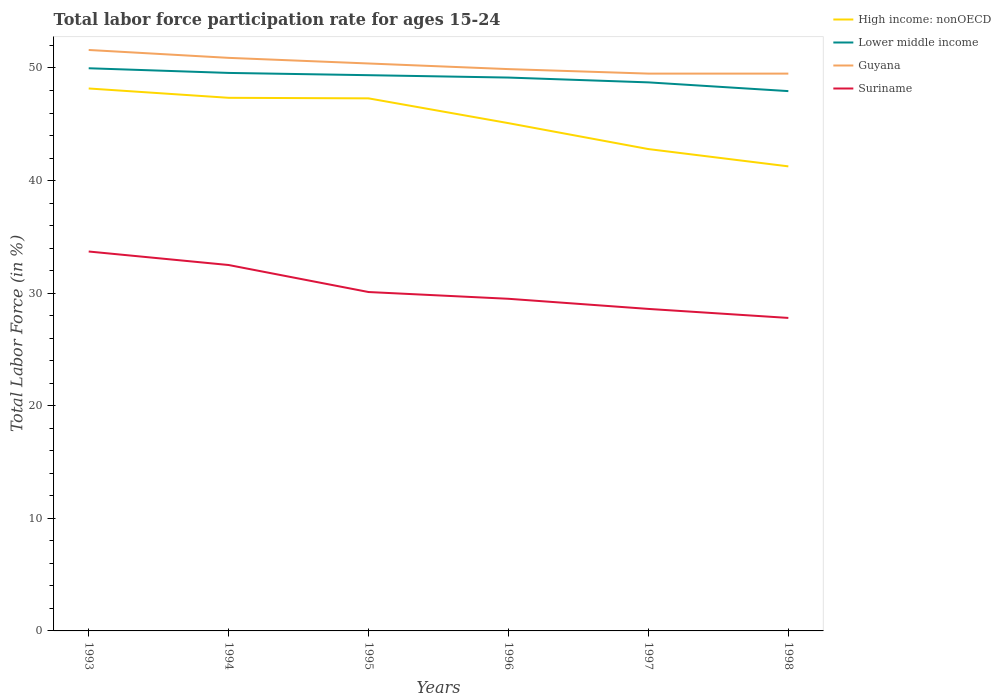Does the line corresponding to Guyana intersect with the line corresponding to Lower middle income?
Provide a succinct answer. No. Across all years, what is the maximum labor force participation rate in Lower middle income?
Ensure brevity in your answer.  47.95. In which year was the labor force participation rate in High income: nonOECD maximum?
Your response must be concise. 1998. What is the total labor force participation rate in High income: nonOECD in the graph?
Provide a succinct answer. 4.55. What is the difference between the highest and the second highest labor force participation rate in Guyana?
Provide a short and direct response. 2.1. Is the labor force participation rate in Lower middle income strictly greater than the labor force participation rate in Suriname over the years?
Give a very brief answer. No. How many lines are there?
Provide a short and direct response. 4. How many years are there in the graph?
Your response must be concise. 6. What is the difference between two consecutive major ticks on the Y-axis?
Provide a succinct answer. 10. Are the values on the major ticks of Y-axis written in scientific E-notation?
Provide a succinct answer. No. Does the graph contain any zero values?
Offer a terse response. No. Does the graph contain grids?
Provide a succinct answer. No. How are the legend labels stacked?
Ensure brevity in your answer.  Vertical. What is the title of the graph?
Ensure brevity in your answer.  Total labor force participation rate for ages 15-24. What is the Total Labor Force (in %) in High income: nonOECD in 1993?
Your answer should be very brief. 48.18. What is the Total Labor Force (in %) in Lower middle income in 1993?
Your response must be concise. 49.98. What is the Total Labor Force (in %) in Guyana in 1993?
Give a very brief answer. 51.6. What is the Total Labor Force (in %) of Suriname in 1993?
Give a very brief answer. 33.7. What is the Total Labor Force (in %) of High income: nonOECD in 1994?
Your answer should be very brief. 47.35. What is the Total Labor Force (in %) in Lower middle income in 1994?
Ensure brevity in your answer.  49.56. What is the Total Labor Force (in %) of Guyana in 1994?
Provide a succinct answer. 50.9. What is the Total Labor Force (in %) of Suriname in 1994?
Give a very brief answer. 32.5. What is the Total Labor Force (in %) of High income: nonOECD in 1995?
Provide a short and direct response. 47.3. What is the Total Labor Force (in %) of Lower middle income in 1995?
Provide a succinct answer. 49.36. What is the Total Labor Force (in %) in Guyana in 1995?
Offer a terse response. 50.4. What is the Total Labor Force (in %) in Suriname in 1995?
Offer a terse response. 30.1. What is the Total Labor Force (in %) of High income: nonOECD in 1996?
Offer a very short reply. 45.1. What is the Total Labor Force (in %) in Lower middle income in 1996?
Ensure brevity in your answer.  49.15. What is the Total Labor Force (in %) of Guyana in 1996?
Your response must be concise. 49.9. What is the Total Labor Force (in %) of Suriname in 1996?
Give a very brief answer. 29.5. What is the Total Labor Force (in %) of High income: nonOECD in 1997?
Give a very brief answer. 42.8. What is the Total Labor Force (in %) of Lower middle income in 1997?
Offer a very short reply. 48.72. What is the Total Labor Force (in %) in Guyana in 1997?
Ensure brevity in your answer.  49.5. What is the Total Labor Force (in %) of Suriname in 1997?
Make the answer very short. 28.6. What is the Total Labor Force (in %) of High income: nonOECD in 1998?
Your answer should be compact. 41.26. What is the Total Labor Force (in %) in Lower middle income in 1998?
Give a very brief answer. 47.95. What is the Total Labor Force (in %) in Guyana in 1998?
Your answer should be compact. 49.5. What is the Total Labor Force (in %) in Suriname in 1998?
Provide a short and direct response. 27.8. Across all years, what is the maximum Total Labor Force (in %) in High income: nonOECD?
Provide a succinct answer. 48.18. Across all years, what is the maximum Total Labor Force (in %) of Lower middle income?
Your answer should be compact. 49.98. Across all years, what is the maximum Total Labor Force (in %) of Guyana?
Offer a very short reply. 51.6. Across all years, what is the maximum Total Labor Force (in %) of Suriname?
Provide a short and direct response. 33.7. Across all years, what is the minimum Total Labor Force (in %) in High income: nonOECD?
Offer a very short reply. 41.26. Across all years, what is the minimum Total Labor Force (in %) of Lower middle income?
Your answer should be compact. 47.95. Across all years, what is the minimum Total Labor Force (in %) in Guyana?
Offer a terse response. 49.5. Across all years, what is the minimum Total Labor Force (in %) in Suriname?
Keep it short and to the point. 27.8. What is the total Total Labor Force (in %) of High income: nonOECD in the graph?
Keep it short and to the point. 271.99. What is the total Total Labor Force (in %) in Lower middle income in the graph?
Your response must be concise. 294.72. What is the total Total Labor Force (in %) of Guyana in the graph?
Provide a short and direct response. 301.8. What is the total Total Labor Force (in %) of Suriname in the graph?
Offer a terse response. 182.2. What is the difference between the Total Labor Force (in %) in High income: nonOECD in 1993 and that in 1994?
Ensure brevity in your answer.  0.83. What is the difference between the Total Labor Force (in %) of Lower middle income in 1993 and that in 1994?
Offer a very short reply. 0.41. What is the difference between the Total Labor Force (in %) in Guyana in 1993 and that in 1994?
Provide a succinct answer. 0.7. What is the difference between the Total Labor Force (in %) in Suriname in 1993 and that in 1994?
Provide a short and direct response. 1.2. What is the difference between the Total Labor Force (in %) of High income: nonOECD in 1993 and that in 1995?
Your answer should be very brief. 0.88. What is the difference between the Total Labor Force (in %) in Lower middle income in 1993 and that in 1995?
Keep it short and to the point. 0.62. What is the difference between the Total Labor Force (in %) of Guyana in 1993 and that in 1995?
Make the answer very short. 1.2. What is the difference between the Total Labor Force (in %) in High income: nonOECD in 1993 and that in 1996?
Make the answer very short. 3.08. What is the difference between the Total Labor Force (in %) in Lower middle income in 1993 and that in 1996?
Your response must be concise. 0.83. What is the difference between the Total Labor Force (in %) in High income: nonOECD in 1993 and that in 1997?
Your response must be concise. 5.38. What is the difference between the Total Labor Force (in %) of Lower middle income in 1993 and that in 1997?
Provide a short and direct response. 1.25. What is the difference between the Total Labor Force (in %) in High income: nonOECD in 1993 and that in 1998?
Your response must be concise. 6.92. What is the difference between the Total Labor Force (in %) in Lower middle income in 1993 and that in 1998?
Your response must be concise. 2.03. What is the difference between the Total Labor Force (in %) in Suriname in 1993 and that in 1998?
Your response must be concise. 5.9. What is the difference between the Total Labor Force (in %) of High income: nonOECD in 1994 and that in 1995?
Offer a terse response. 0.05. What is the difference between the Total Labor Force (in %) of Lower middle income in 1994 and that in 1995?
Keep it short and to the point. 0.2. What is the difference between the Total Labor Force (in %) in Suriname in 1994 and that in 1995?
Your answer should be very brief. 2.4. What is the difference between the Total Labor Force (in %) in High income: nonOECD in 1994 and that in 1996?
Give a very brief answer. 2.25. What is the difference between the Total Labor Force (in %) in Lower middle income in 1994 and that in 1996?
Your answer should be very brief. 0.41. What is the difference between the Total Labor Force (in %) of High income: nonOECD in 1994 and that in 1997?
Provide a short and direct response. 4.55. What is the difference between the Total Labor Force (in %) in Lower middle income in 1994 and that in 1997?
Provide a succinct answer. 0.84. What is the difference between the Total Labor Force (in %) of Guyana in 1994 and that in 1997?
Your answer should be very brief. 1.4. What is the difference between the Total Labor Force (in %) in Suriname in 1994 and that in 1997?
Ensure brevity in your answer.  3.9. What is the difference between the Total Labor Force (in %) in High income: nonOECD in 1994 and that in 1998?
Offer a terse response. 6.09. What is the difference between the Total Labor Force (in %) in Lower middle income in 1994 and that in 1998?
Offer a very short reply. 1.62. What is the difference between the Total Labor Force (in %) of High income: nonOECD in 1995 and that in 1996?
Your response must be concise. 2.2. What is the difference between the Total Labor Force (in %) in Lower middle income in 1995 and that in 1996?
Offer a very short reply. 0.21. What is the difference between the Total Labor Force (in %) of Guyana in 1995 and that in 1996?
Your answer should be very brief. 0.5. What is the difference between the Total Labor Force (in %) in High income: nonOECD in 1995 and that in 1997?
Provide a succinct answer. 4.5. What is the difference between the Total Labor Force (in %) in Lower middle income in 1995 and that in 1997?
Offer a terse response. 0.64. What is the difference between the Total Labor Force (in %) in Guyana in 1995 and that in 1997?
Your answer should be very brief. 0.9. What is the difference between the Total Labor Force (in %) of High income: nonOECD in 1995 and that in 1998?
Provide a short and direct response. 6.04. What is the difference between the Total Labor Force (in %) in Lower middle income in 1995 and that in 1998?
Provide a succinct answer. 1.41. What is the difference between the Total Labor Force (in %) of Suriname in 1995 and that in 1998?
Offer a terse response. 2.3. What is the difference between the Total Labor Force (in %) in High income: nonOECD in 1996 and that in 1997?
Offer a very short reply. 2.3. What is the difference between the Total Labor Force (in %) of Lower middle income in 1996 and that in 1997?
Offer a very short reply. 0.43. What is the difference between the Total Labor Force (in %) in Guyana in 1996 and that in 1997?
Provide a short and direct response. 0.4. What is the difference between the Total Labor Force (in %) in Suriname in 1996 and that in 1997?
Offer a very short reply. 0.9. What is the difference between the Total Labor Force (in %) of High income: nonOECD in 1996 and that in 1998?
Offer a terse response. 3.84. What is the difference between the Total Labor Force (in %) of Lower middle income in 1996 and that in 1998?
Provide a succinct answer. 1.2. What is the difference between the Total Labor Force (in %) in High income: nonOECD in 1997 and that in 1998?
Make the answer very short. 1.54. What is the difference between the Total Labor Force (in %) in Lower middle income in 1997 and that in 1998?
Ensure brevity in your answer.  0.78. What is the difference between the Total Labor Force (in %) of High income: nonOECD in 1993 and the Total Labor Force (in %) of Lower middle income in 1994?
Your answer should be very brief. -1.38. What is the difference between the Total Labor Force (in %) of High income: nonOECD in 1993 and the Total Labor Force (in %) of Guyana in 1994?
Offer a terse response. -2.72. What is the difference between the Total Labor Force (in %) of High income: nonOECD in 1993 and the Total Labor Force (in %) of Suriname in 1994?
Ensure brevity in your answer.  15.68. What is the difference between the Total Labor Force (in %) in Lower middle income in 1993 and the Total Labor Force (in %) in Guyana in 1994?
Make the answer very short. -0.92. What is the difference between the Total Labor Force (in %) of Lower middle income in 1993 and the Total Labor Force (in %) of Suriname in 1994?
Provide a short and direct response. 17.48. What is the difference between the Total Labor Force (in %) of Guyana in 1993 and the Total Labor Force (in %) of Suriname in 1994?
Your response must be concise. 19.1. What is the difference between the Total Labor Force (in %) in High income: nonOECD in 1993 and the Total Labor Force (in %) in Lower middle income in 1995?
Offer a terse response. -1.18. What is the difference between the Total Labor Force (in %) of High income: nonOECD in 1993 and the Total Labor Force (in %) of Guyana in 1995?
Provide a succinct answer. -2.22. What is the difference between the Total Labor Force (in %) in High income: nonOECD in 1993 and the Total Labor Force (in %) in Suriname in 1995?
Offer a very short reply. 18.08. What is the difference between the Total Labor Force (in %) of Lower middle income in 1993 and the Total Labor Force (in %) of Guyana in 1995?
Give a very brief answer. -0.42. What is the difference between the Total Labor Force (in %) in Lower middle income in 1993 and the Total Labor Force (in %) in Suriname in 1995?
Provide a succinct answer. 19.88. What is the difference between the Total Labor Force (in %) in Guyana in 1993 and the Total Labor Force (in %) in Suriname in 1995?
Give a very brief answer. 21.5. What is the difference between the Total Labor Force (in %) in High income: nonOECD in 1993 and the Total Labor Force (in %) in Lower middle income in 1996?
Give a very brief answer. -0.97. What is the difference between the Total Labor Force (in %) in High income: nonOECD in 1993 and the Total Labor Force (in %) in Guyana in 1996?
Provide a short and direct response. -1.72. What is the difference between the Total Labor Force (in %) of High income: nonOECD in 1993 and the Total Labor Force (in %) of Suriname in 1996?
Make the answer very short. 18.68. What is the difference between the Total Labor Force (in %) in Lower middle income in 1993 and the Total Labor Force (in %) in Guyana in 1996?
Your answer should be very brief. 0.08. What is the difference between the Total Labor Force (in %) in Lower middle income in 1993 and the Total Labor Force (in %) in Suriname in 1996?
Your answer should be compact. 20.48. What is the difference between the Total Labor Force (in %) in Guyana in 1993 and the Total Labor Force (in %) in Suriname in 1996?
Give a very brief answer. 22.1. What is the difference between the Total Labor Force (in %) in High income: nonOECD in 1993 and the Total Labor Force (in %) in Lower middle income in 1997?
Make the answer very short. -0.54. What is the difference between the Total Labor Force (in %) of High income: nonOECD in 1993 and the Total Labor Force (in %) of Guyana in 1997?
Your answer should be very brief. -1.32. What is the difference between the Total Labor Force (in %) in High income: nonOECD in 1993 and the Total Labor Force (in %) in Suriname in 1997?
Make the answer very short. 19.58. What is the difference between the Total Labor Force (in %) of Lower middle income in 1993 and the Total Labor Force (in %) of Guyana in 1997?
Your answer should be very brief. 0.48. What is the difference between the Total Labor Force (in %) of Lower middle income in 1993 and the Total Labor Force (in %) of Suriname in 1997?
Ensure brevity in your answer.  21.38. What is the difference between the Total Labor Force (in %) in High income: nonOECD in 1993 and the Total Labor Force (in %) in Lower middle income in 1998?
Give a very brief answer. 0.23. What is the difference between the Total Labor Force (in %) in High income: nonOECD in 1993 and the Total Labor Force (in %) in Guyana in 1998?
Provide a short and direct response. -1.32. What is the difference between the Total Labor Force (in %) in High income: nonOECD in 1993 and the Total Labor Force (in %) in Suriname in 1998?
Your answer should be very brief. 20.38. What is the difference between the Total Labor Force (in %) in Lower middle income in 1993 and the Total Labor Force (in %) in Guyana in 1998?
Keep it short and to the point. 0.48. What is the difference between the Total Labor Force (in %) in Lower middle income in 1993 and the Total Labor Force (in %) in Suriname in 1998?
Provide a succinct answer. 22.18. What is the difference between the Total Labor Force (in %) of Guyana in 1993 and the Total Labor Force (in %) of Suriname in 1998?
Your answer should be compact. 23.8. What is the difference between the Total Labor Force (in %) in High income: nonOECD in 1994 and the Total Labor Force (in %) in Lower middle income in 1995?
Make the answer very short. -2.01. What is the difference between the Total Labor Force (in %) in High income: nonOECD in 1994 and the Total Labor Force (in %) in Guyana in 1995?
Your answer should be compact. -3.05. What is the difference between the Total Labor Force (in %) in High income: nonOECD in 1994 and the Total Labor Force (in %) in Suriname in 1995?
Give a very brief answer. 17.25. What is the difference between the Total Labor Force (in %) of Lower middle income in 1994 and the Total Labor Force (in %) of Guyana in 1995?
Your response must be concise. -0.84. What is the difference between the Total Labor Force (in %) in Lower middle income in 1994 and the Total Labor Force (in %) in Suriname in 1995?
Give a very brief answer. 19.46. What is the difference between the Total Labor Force (in %) of Guyana in 1994 and the Total Labor Force (in %) of Suriname in 1995?
Ensure brevity in your answer.  20.8. What is the difference between the Total Labor Force (in %) of High income: nonOECD in 1994 and the Total Labor Force (in %) of Lower middle income in 1996?
Provide a short and direct response. -1.8. What is the difference between the Total Labor Force (in %) of High income: nonOECD in 1994 and the Total Labor Force (in %) of Guyana in 1996?
Provide a succinct answer. -2.55. What is the difference between the Total Labor Force (in %) of High income: nonOECD in 1994 and the Total Labor Force (in %) of Suriname in 1996?
Provide a succinct answer. 17.85. What is the difference between the Total Labor Force (in %) of Lower middle income in 1994 and the Total Labor Force (in %) of Guyana in 1996?
Ensure brevity in your answer.  -0.34. What is the difference between the Total Labor Force (in %) of Lower middle income in 1994 and the Total Labor Force (in %) of Suriname in 1996?
Provide a short and direct response. 20.06. What is the difference between the Total Labor Force (in %) in Guyana in 1994 and the Total Labor Force (in %) in Suriname in 1996?
Provide a succinct answer. 21.4. What is the difference between the Total Labor Force (in %) of High income: nonOECD in 1994 and the Total Labor Force (in %) of Lower middle income in 1997?
Make the answer very short. -1.37. What is the difference between the Total Labor Force (in %) in High income: nonOECD in 1994 and the Total Labor Force (in %) in Guyana in 1997?
Your response must be concise. -2.15. What is the difference between the Total Labor Force (in %) of High income: nonOECD in 1994 and the Total Labor Force (in %) of Suriname in 1997?
Provide a succinct answer. 18.75. What is the difference between the Total Labor Force (in %) in Lower middle income in 1994 and the Total Labor Force (in %) in Guyana in 1997?
Your answer should be compact. 0.06. What is the difference between the Total Labor Force (in %) in Lower middle income in 1994 and the Total Labor Force (in %) in Suriname in 1997?
Your answer should be very brief. 20.96. What is the difference between the Total Labor Force (in %) in Guyana in 1994 and the Total Labor Force (in %) in Suriname in 1997?
Your answer should be very brief. 22.3. What is the difference between the Total Labor Force (in %) of High income: nonOECD in 1994 and the Total Labor Force (in %) of Lower middle income in 1998?
Give a very brief answer. -0.59. What is the difference between the Total Labor Force (in %) of High income: nonOECD in 1994 and the Total Labor Force (in %) of Guyana in 1998?
Your answer should be compact. -2.15. What is the difference between the Total Labor Force (in %) of High income: nonOECD in 1994 and the Total Labor Force (in %) of Suriname in 1998?
Your response must be concise. 19.55. What is the difference between the Total Labor Force (in %) in Lower middle income in 1994 and the Total Labor Force (in %) in Guyana in 1998?
Keep it short and to the point. 0.06. What is the difference between the Total Labor Force (in %) in Lower middle income in 1994 and the Total Labor Force (in %) in Suriname in 1998?
Make the answer very short. 21.76. What is the difference between the Total Labor Force (in %) in Guyana in 1994 and the Total Labor Force (in %) in Suriname in 1998?
Your answer should be very brief. 23.1. What is the difference between the Total Labor Force (in %) in High income: nonOECD in 1995 and the Total Labor Force (in %) in Lower middle income in 1996?
Ensure brevity in your answer.  -1.85. What is the difference between the Total Labor Force (in %) in High income: nonOECD in 1995 and the Total Labor Force (in %) in Guyana in 1996?
Provide a short and direct response. -2.6. What is the difference between the Total Labor Force (in %) of High income: nonOECD in 1995 and the Total Labor Force (in %) of Suriname in 1996?
Give a very brief answer. 17.8. What is the difference between the Total Labor Force (in %) in Lower middle income in 1995 and the Total Labor Force (in %) in Guyana in 1996?
Provide a succinct answer. -0.54. What is the difference between the Total Labor Force (in %) of Lower middle income in 1995 and the Total Labor Force (in %) of Suriname in 1996?
Offer a terse response. 19.86. What is the difference between the Total Labor Force (in %) in Guyana in 1995 and the Total Labor Force (in %) in Suriname in 1996?
Ensure brevity in your answer.  20.9. What is the difference between the Total Labor Force (in %) of High income: nonOECD in 1995 and the Total Labor Force (in %) of Lower middle income in 1997?
Give a very brief answer. -1.42. What is the difference between the Total Labor Force (in %) in High income: nonOECD in 1995 and the Total Labor Force (in %) in Guyana in 1997?
Ensure brevity in your answer.  -2.2. What is the difference between the Total Labor Force (in %) of High income: nonOECD in 1995 and the Total Labor Force (in %) of Suriname in 1997?
Provide a succinct answer. 18.7. What is the difference between the Total Labor Force (in %) of Lower middle income in 1995 and the Total Labor Force (in %) of Guyana in 1997?
Provide a succinct answer. -0.14. What is the difference between the Total Labor Force (in %) in Lower middle income in 1995 and the Total Labor Force (in %) in Suriname in 1997?
Make the answer very short. 20.76. What is the difference between the Total Labor Force (in %) of Guyana in 1995 and the Total Labor Force (in %) of Suriname in 1997?
Your answer should be very brief. 21.8. What is the difference between the Total Labor Force (in %) of High income: nonOECD in 1995 and the Total Labor Force (in %) of Lower middle income in 1998?
Offer a very short reply. -0.64. What is the difference between the Total Labor Force (in %) of High income: nonOECD in 1995 and the Total Labor Force (in %) of Guyana in 1998?
Your response must be concise. -2.2. What is the difference between the Total Labor Force (in %) of High income: nonOECD in 1995 and the Total Labor Force (in %) of Suriname in 1998?
Offer a terse response. 19.5. What is the difference between the Total Labor Force (in %) in Lower middle income in 1995 and the Total Labor Force (in %) in Guyana in 1998?
Provide a succinct answer. -0.14. What is the difference between the Total Labor Force (in %) in Lower middle income in 1995 and the Total Labor Force (in %) in Suriname in 1998?
Provide a succinct answer. 21.56. What is the difference between the Total Labor Force (in %) in Guyana in 1995 and the Total Labor Force (in %) in Suriname in 1998?
Offer a very short reply. 22.6. What is the difference between the Total Labor Force (in %) in High income: nonOECD in 1996 and the Total Labor Force (in %) in Lower middle income in 1997?
Provide a short and direct response. -3.62. What is the difference between the Total Labor Force (in %) of High income: nonOECD in 1996 and the Total Labor Force (in %) of Guyana in 1997?
Offer a very short reply. -4.4. What is the difference between the Total Labor Force (in %) of High income: nonOECD in 1996 and the Total Labor Force (in %) of Suriname in 1997?
Provide a succinct answer. 16.5. What is the difference between the Total Labor Force (in %) of Lower middle income in 1996 and the Total Labor Force (in %) of Guyana in 1997?
Give a very brief answer. -0.35. What is the difference between the Total Labor Force (in %) of Lower middle income in 1996 and the Total Labor Force (in %) of Suriname in 1997?
Your response must be concise. 20.55. What is the difference between the Total Labor Force (in %) of Guyana in 1996 and the Total Labor Force (in %) of Suriname in 1997?
Keep it short and to the point. 21.3. What is the difference between the Total Labor Force (in %) in High income: nonOECD in 1996 and the Total Labor Force (in %) in Lower middle income in 1998?
Give a very brief answer. -2.85. What is the difference between the Total Labor Force (in %) in High income: nonOECD in 1996 and the Total Labor Force (in %) in Guyana in 1998?
Make the answer very short. -4.4. What is the difference between the Total Labor Force (in %) in High income: nonOECD in 1996 and the Total Labor Force (in %) in Suriname in 1998?
Your response must be concise. 17.3. What is the difference between the Total Labor Force (in %) of Lower middle income in 1996 and the Total Labor Force (in %) of Guyana in 1998?
Make the answer very short. -0.35. What is the difference between the Total Labor Force (in %) of Lower middle income in 1996 and the Total Labor Force (in %) of Suriname in 1998?
Give a very brief answer. 21.35. What is the difference between the Total Labor Force (in %) in Guyana in 1996 and the Total Labor Force (in %) in Suriname in 1998?
Provide a short and direct response. 22.1. What is the difference between the Total Labor Force (in %) in High income: nonOECD in 1997 and the Total Labor Force (in %) in Lower middle income in 1998?
Provide a short and direct response. -5.15. What is the difference between the Total Labor Force (in %) in High income: nonOECD in 1997 and the Total Labor Force (in %) in Guyana in 1998?
Offer a terse response. -6.7. What is the difference between the Total Labor Force (in %) of High income: nonOECD in 1997 and the Total Labor Force (in %) of Suriname in 1998?
Give a very brief answer. 15. What is the difference between the Total Labor Force (in %) in Lower middle income in 1997 and the Total Labor Force (in %) in Guyana in 1998?
Give a very brief answer. -0.78. What is the difference between the Total Labor Force (in %) of Lower middle income in 1997 and the Total Labor Force (in %) of Suriname in 1998?
Your answer should be very brief. 20.92. What is the difference between the Total Labor Force (in %) in Guyana in 1997 and the Total Labor Force (in %) in Suriname in 1998?
Give a very brief answer. 21.7. What is the average Total Labor Force (in %) in High income: nonOECD per year?
Provide a succinct answer. 45.33. What is the average Total Labor Force (in %) of Lower middle income per year?
Offer a terse response. 49.12. What is the average Total Labor Force (in %) in Guyana per year?
Your response must be concise. 50.3. What is the average Total Labor Force (in %) in Suriname per year?
Your answer should be very brief. 30.37. In the year 1993, what is the difference between the Total Labor Force (in %) in High income: nonOECD and Total Labor Force (in %) in Lower middle income?
Offer a very short reply. -1.8. In the year 1993, what is the difference between the Total Labor Force (in %) in High income: nonOECD and Total Labor Force (in %) in Guyana?
Make the answer very short. -3.42. In the year 1993, what is the difference between the Total Labor Force (in %) of High income: nonOECD and Total Labor Force (in %) of Suriname?
Offer a terse response. 14.48. In the year 1993, what is the difference between the Total Labor Force (in %) in Lower middle income and Total Labor Force (in %) in Guyana?
Give a very brief answer. -1.62. In the year 1993, what is the difference between the Total Labor Force (in %) of Lower middle income and Total Labor Force (in %) of Suriname?
Your response must be concise. 16.28. In the year 1993, what is the difference between the Total Labor Force (in %) of Guyana and Total Labor Force (in %) of Suriname?
Make the answer very short. 17.9. In the year 1994, what is the difference between the Total Labor Force (in %) of High income: nonOECD and Total Labor Force (in %) of Lower middle income?
Your response must be concise. -2.21. In the year 1994, what is the difference between the Total Labor Force (in %) of High income: nonOECD and Total Labor Force (in %) of Guyana?
Offer a terse response. -3.55. In the year 1994, what is the difference between the Total Labor Force (in %) of High income: nonOECD and Total Labor Force (in %) of Suriname?
Your response must be concise. 14.85. In the year 1994, what is the difference between the Total Labor Force (in %) of Lower middle income and Total Labor Force (in %) of Guyana?
Offer a very short reply. -1.34. In the year 1994, what is the difference between the Total Labor Force (in %) in Lower middle income and Total Labor Force (in %) in Suriname?
Your response must be concise. 17.06. In the year 1994, what is the difference between the Total Labor Force (in %) in Guyana and Total Labor Force (in %) in Suriname?
Your answer should be compact. 18.4. In the year 1995, what is the difference between the Total Labor Force (in %) of High income: nonOECD and Total Labor Force (in %) of Lower middle income?
Make the answer very short. -2.06. In the year 1995, what is the difference between the Total Labor Force (in %) of High income: nonOECD and Total Labor Force (in %) of Guyana?
Provide a succinct answer. -3.1. In the year 1995, what is the difference between the Total Labor Force (in %) in High income: nonOECD and Total Labor Force (in %) in Suriname?
Offer a terse response. 17.2. In the year 1995, what is the difference between the Total Labor Force (in %) of Lower middle income and Total Labor Force (in %) of Guyana?
Your answer should be very brief. -1.04. In the year 1995, what is the difference between the Total Labor Force (in %) of Lower middle income and Total Labor Force (in %) of Suriname?
Offer a terse response. 19.26. In the year 1995, what is the difference between the Total Labor Force (in %) in Guyana and Total Labor Force (in %) in Suriname?
Provide a short and direct response. 20.3. In the year 1996, what is the difference between the Total Labor Force (in %) of High income: nonOECD and Total Labor Force (in %) of Lower middle income?
Ensure brevity in your answer.  -4.05. In the year 1996, what is the difference between the Total Labor Force (in %) of High income: nonOECD and Total Labor Force (in %) of Guyana?
Ensure brevity in your answer.  -4.8. In the year 1996, what is the difference between the Total Labor Force (in %) in High income: nonOECD and Total Labor Force (in %) in Suriname?
Give a very brief answer. 15.6. In the year 1996, what is the difference between the Total Labor Force (in %) of Lower middle income and Total Labor Force (in %) of Guyana?
Provide a short and direct response. -0.75. In the year 1996, what is the difference between the Total Labor Force (in %) in Lower middle income and Total Labor Force (in %) in Suriname?
Your answer should be very brief. 19.65. In the year 1996, what is the difference between the Total Labor Force (in %) of Guyana and Total Labor Force (in %) of Suriname?
Offer a terse response. 20.4. In the year 1997, what is the difference between the Total Labor Force (in %) of High income: nonOECD and Total Labor Force (in %) of Lower middle income?
Keep it short and to the point. -5.92. In the year 1997, what is the difference between the Total Labor Force (in %) of High income: nonOECD and Total Labor Force (in %) of Guyana?
Make the answer very short. -6.7. In the year 1997, what is the difference between the Total Labor Force (in %) in High income: nonOECD and Total Labor Force (in %) in Suriname?
Provide a succinct answer. 14.2. In the year 1997, what is the difference between the Total Labor Force (in %) in Lower middle income and Total Labor Force (in %) in Guyana?
Ensure brevity in your answer.  -0.78. In the year 1997, what is the difference between the Total Labor Force (in %) in Lower middle income and Total Labor Force (in %) in Suriname?
Offer a very short reply. 20.12. In the year 1997, what is the difference between the Total Labor Force (in %) in Guyana and Total Labor Force (in %) in Suriname?
Provide a succinct answer. 20.9. In the year 1998, what is the difference between the Total Labor Force (in %) in High income: nonOECD and Total Labor Force (in %) in Lower middle income?
Your response must be concise. -6.68. In the year 1998, what is the difference between the Total Labor Force (in %) in High income: nonOECD and Total Labor Force (in %) in Guyana?
Offer a terse response. -8.24. In the year 1998, what is the difference between the Total Labor Force (in %) in High income: nonOECD and Total Labor Force (in %) in Suriname?
Your answer should be compact. 13.46. In the year 1998, what is the difference between the Total Labor Force (in %) in Lower middle income and Total Labor Force (in %) in Guyana?
Your response must be concise. -1.55. In the year 1998, what is the difference between the Total Labor Force (in %) of Lower middle income and Total Labor Force (in %) of Suriname?
Provide a short and direct response. 20.15. In the year 1998, what is the difference between the Total Labor Force (in %) of Guyana and Total Labor Force (in %) of Suriname?
Offer a very short reply. 21.7. What is the ratio of the Total Labor Force (in %) of High income: nonOECD in 1993 to that in 1994?
Your answer should be very brief. 1.02. What is the ratio of the Total Labor Force (in %) of Lower middle income in 1993 to that in 1994?
Keep it short and to the point. 1.01. What is the ratio of the Total Labor Force (in %) of Guyana in 1993 to that in 1994?
Provide a short and direct response. 1.01. What is the ratio of the Total Labor Force (in %) in Suriname in 1993 to that in 1994?
Provide a succinct answer. 1.04. What is the ratio of the Total Labor Force (in %) of High income: nonOECD in 1993 to that in 1995?
Your response must be concise. 1.02. What is the ratio of the Total Labor Force (in %) of Lower middle income in 1993 to that in 1995?
Keep it short and to the point. 1.01. What is the ratio of the Total Labor Force (in %) of Guyana in 1993 to that in 1995?
Make the answer very short. 1.02. What is the ratio of the Total Labor Force (in %) in Suriname in 1993 to that in 1995?
Provide a succinct answer. 1.12. What is the ratio of the Total Labor Force (in %) of High income: nonOECD in 1993 to that in 1996?
Provide a short and direct response. 1.07. What is the ratio of the Total Labor Force (in %) in Lower middle income in 1993 to that in 1996?
Provide a succinct answer. 1.02. What is the ratio of the Total Labor Force (in %) in Guyana in 1993 to that in 1996?
Offer a terse response. 1.03. What is the ratio of the Total Labor Force (in %) of Suriname in 1993 to that in 1996?
Make the answer very short. 1.14. What is the ratio of the Total Labor Force (in %) of High income: nonOECD in 1993 to that in 1997?
Provide a succinct answer. 1.13. What is the ratio of the Total Labor Force (in %) of Lower middle income in 1993 to that in 1997?
Your answer should be very brief. 1.03. What is the ratio of the Total Labor Force (in %) in Guyana in 1993 to that in 1997?
Keep it short and to the point. 1.04. What is the ratio of the Total Labor Force (in %) of Suriname in 1993 to that in 1997?
Make the answer very short. 1.18. What is the ratio of the Total Labor Force (in %) of High income: nonOECD in 1993 to that in 1998?
Provide a succinct answer. 1.17. What is the ratio of the Total Labor Force (in %) of Lower middle income in 1993 to that in 1998?
Keep it short and to the point. 1.04. What is the ratio of the Total Labor Force (in %) in Guyana in 1993 to that in 1998?
Provide a succinct answer. 1.04. What is the ratio of the Total Labor Force (in %) of Suriname in 1993 to that in 1998?
Offer a terse response. 1.21. What is the ratio of the Total Labor Force (in %) in High income: nonOECD in 1994 to that in 1995?
Your answer should be very brief. 1. What is the ratio of the Total Labor Force (in %) in Lower middle income in 1994 to that in 1995?
Give a very brief answer. 1. What is the ratio of the Total Labor Force (in %) of Guyana in 1994 to that in 1995?
Make the answer very short. 1.01. What is the ratio of the Total Labor Force (in %) of Suriname in 1994 to that in 1995?
Give a very brief answer. 1.08. What is the ratio of the Total Labor Force (in %) of High income: nonOECD in 1994 to that in 1996?
Your response must be concise. 1.05. What is the ratio of the Total Labor Force (in %) of Lower middle income in 1994 to that in 1996?
Offer a terse response. 1.01. What is the ratio of the Total Labor Force (in %) in Suriname in 1994 to that in 1996?
Ensure brevity in your answer.  1.1. What is the ratio of the Total Labor Force (in %) of High income: nonOECD in 1994 to that in 1997?
Keep it short and to the point. 1.11. What is the ratio of the Total Labor Force (in %) of Lower middle income in 1994 to that in 1997?
Your answer should be compact. 1.02. What is the ratio of the Total Labor Force (in %) of Guyana in 1994 to that in 1997?
Keep it short and to the point. 1.03. What is the ratio of the Total Labor Force (in %) in Suriname in 1994 to that in 1997?
Provide a short and direct response. 1.14. What is the ratio of the Total Labor Force (in %) of High income: nonOECD in 1994 to that in 1998?
Make the answer very short. 1.15. What is the ratio of the Total Labor Force (in %) in Lower middle income in 1994 to that in 1998?
Provide a succinct answer. 1.03. What is the ratio of the Total Labor Force (in %) in Guyana in 1994 to that in 1998?
Offer a very short reply. 1.03. What is the ratio of the Total Labor Force (in %) in Suriname in 1994 to that in 1998?
Offer a terse response. 1.17. What is the ratio of the Total Labor Force (in %) of High income: nonOECD in 1995 to that in 1996?
Offer a terse response. 1.05. What is the ratio of the Total Labor Force (in %) of Lower middle income in 1995 to that in 1996?
Offer a terse response. 1. What is the ratio of the Total Labor Force (in %) of Guyana in 1995 to that in 1996?
Your answer should be compact. 1.01. What is the ratio of the Total Labor Force (in %) in Suriname in 1995 to that in 1996?
Provide a short and direct response. 1.02. What is the ratio of the Total Labor Force (in %) in High income: nonOECD in 1995 to that in 1997?
Keep it short and to the point. 1.11. What is the ratio of the Total Labor Force (in %) in Lower middle income in 1995 to that in 1997?
Offer a very short reply. 1.01. What is the ratio of the Total Labor Force (in %) in Guyana in 1995 to that in 1997?
Give a very brief answer. 1.02. What is the ratio of the Total Labor Force (in %) of Suriname in 1995 to that in 1997?
Provide a succinct answer. 1.05. What is the ratio of the Total Labor Force (in %) in High income: nonOECD in 1995 to that in 1998?
Offer a terse response. 1.15. What is the ratio of the Total Labor Force (in %) in Lower middle income in 1995 to that in 1998?
Your response must be concise. 1.03. What is the ratio of the Total Labor Force (in %) of Guyana in 1995 to that in 1998?
Your answer should be very brief. 1.02. What is the ratio of the Total Labor Force (in %) in Suriname in 1995 to that in 1998?
Your answer should be very brief. 1.08. What is the ratio of the Total Labor Force (in %) of High income: nonOECD in 1996 to that in 1997?
Make the answer very short. 1.05. What is the ratio of the Total Labor Force (in %) of Lower middle income in 1996 to that in 1997?
Your answer should be compact. 1.01. What is the ratio of the Total Labor Force (in %) in Suriname in 1996 to that in 1997?
Make the answer very short. 1.03. What is the ratio of the Total Labor Force (in %) of High income: nonOECD in 1996 to that in 1998?
Make the answer very short. 1.09. What is the ratio of the Total Labor Force (in %) of Lower middle income in 1996 to that in 1998?
Make the answer very short. 1.03. What is the ratio of the Total Labor Force (in %) of Guyana in 1996 to that in 1998?
Ensure brevity in your answer.  1.01. What is the ratio of the Total Labor Force (in %) in Suriname in 1996 to that in 1998?
Offer a terse response. 1.06. What is the ratio of the Total Labor Force (in %) of High income: nonOECD in 1997 to that in 1998?
Give a very brief answer. 1.04. What is the ratio of the Total Labor Force (in %) of Lower middle income in 1997 to that in 1998?
Offer a terse response. 1.02. What is the ratio of the Total Labor Force (in %) in Guyana in 1997 to that in 1998?
Offer a very short reply. 1. What is the ratio of the Total Labor Force (in %) of Suriname in 1997 to that in 1998?
Make the answer very short. 1.03. What is the difference between the highest and the second highest Total Labor Force (in %) in High income: nonOECD?
Keep it short and to the point. 0.83. What is the difference between the highest and the second highest Total Labor Force (in %) of Lower middle income?
Ensure brevity in your answer.  0.41. What is the difference between the highest and the second highest Total Labor Force (in %) in Suriname?
Your answer should be very brief. 1.2. What is the difference between the highest and the lowest Total Labor Force (in %) of High income: nonOECD?
Your answer should be compact. 6.92. What is the difference between the highest and the lowest Total Labor Force (in %) of Lower middle income?
Give a very brief answer. 2.03. 